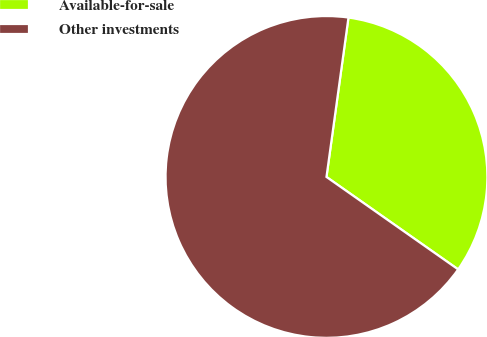Convert chart. <chart><loc_0><loc_0><loc_500><loc_500><pie_chart><fcel>Available-for-sale<fcel>Other investments<nl><fcel>32.56%<fcel>67.44%<nl></chart> 